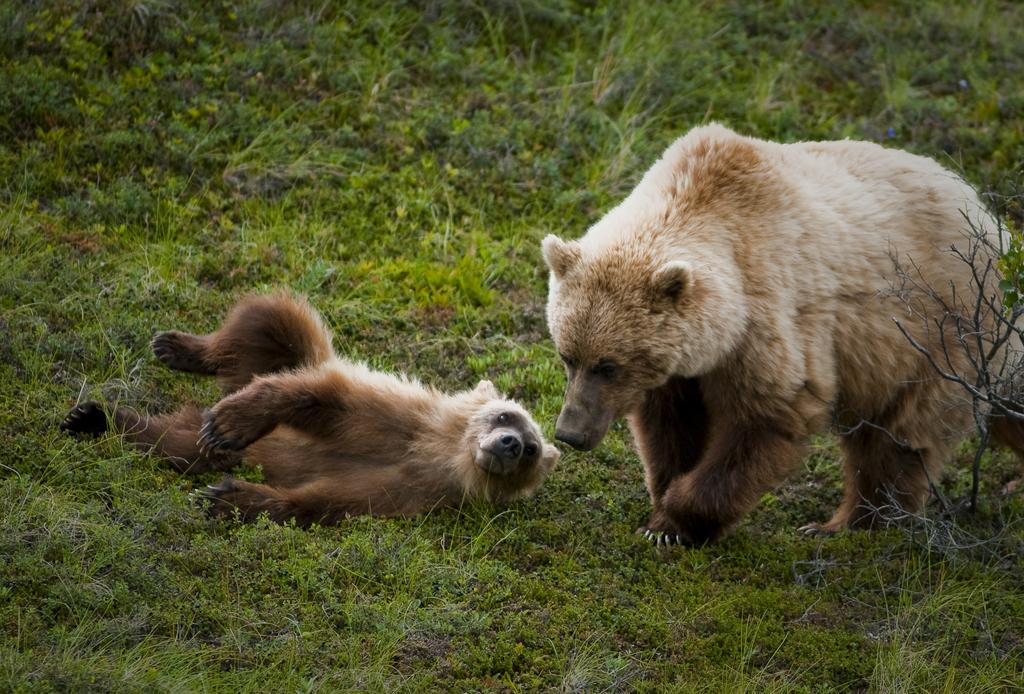What types of living organisms are present in the image? There are animals in the image. Can you describe the color patterns of the animals? The animals have cream, brown, and black colors. What type of natural environment is visible in the image? There is green color grass in the image. What type of van can be seen parked on the grass in the image? There is no van present in the image; it only features animals and green grass. 